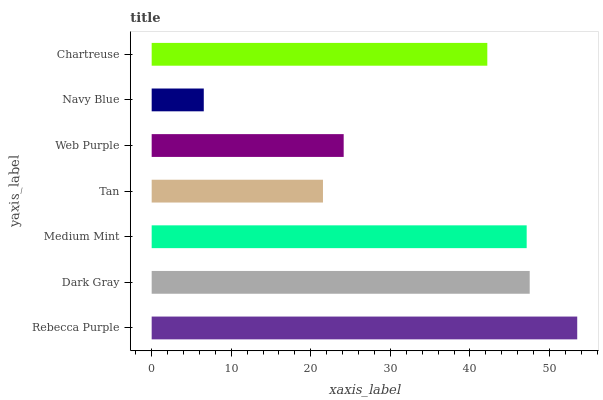Is Navy Blue the minimum?
Answer yes or no. Yes. Is Rebecca Purple the maximum?
Answer yes or no. Yes. Is Dark Gray the minimum?
Answer yes or no. No. Is Dark Gray the maximum?
Answer yes or no. No. Is Rebecca Purple greater than Dark Gray?
Answer yes or no. Yes. Is Dark Gray less than Rebecca Purple?
Answer yes or no. Yes. Is Dark Gray greater than Rebecca Purple?
Answer yes or no. No. Is Rebecca Purple less than Dark Gray?
Answer yes or no. No. Is Chartreuse the high median?
Answer yes or no. Yes. Is Chartreuse the low median?
Answer yes or no. Yes. Is Tan the high median?
Answer yes or no. No. Is Navy Blue the low median?
Answer yes or no. No. 